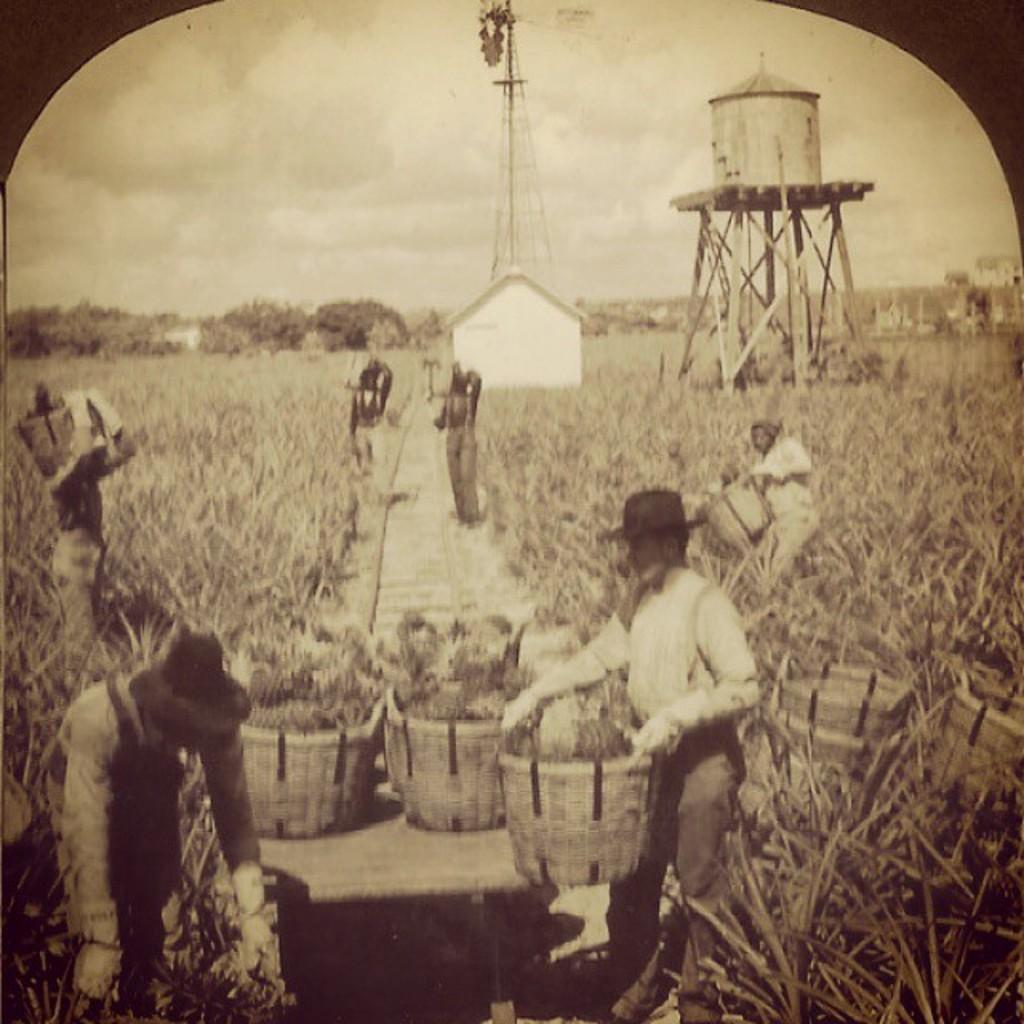What type of living organisms can be seen in the image? Plants are visible in the image. Can you describe the people in the image? There is a group of people in the image. What objects are present in the image? Baskets are present in the image. What structures can be seen in the background of the image? There are towers, a house, and trees in the background of the image. What is the color scheme of the image? The image is in black and white. Where is the drain located in the image? There is no drain present in the image. What type of mitten is being worn by the people in the image? There are no mittens visible in the image; the people are not wearing any. 